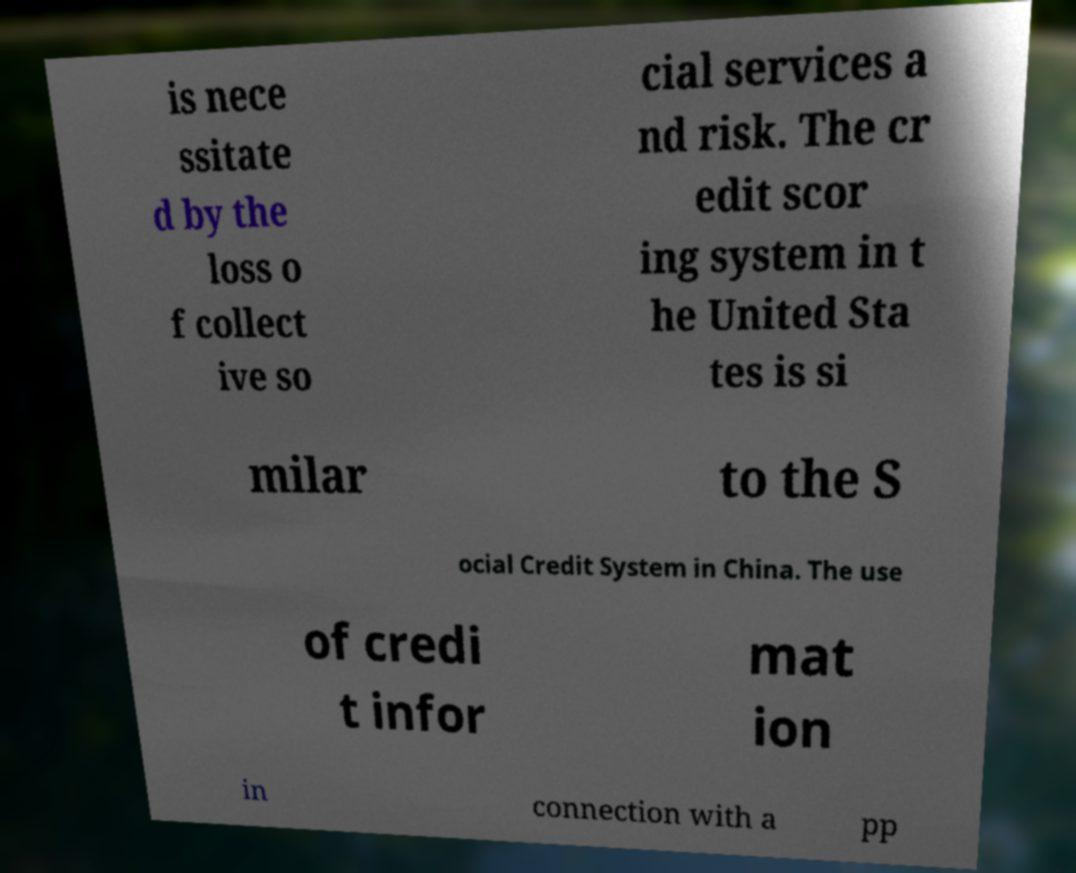Please identify and transcribe the text found in this image. is nece ssitate d by the loss o f collect ive so cial services a nd risk. The cr edit scor ing system in t he United Sta tes is si milar to the S ocial Credit System in China. The use of credi t infor mat ion in connection with a pp 